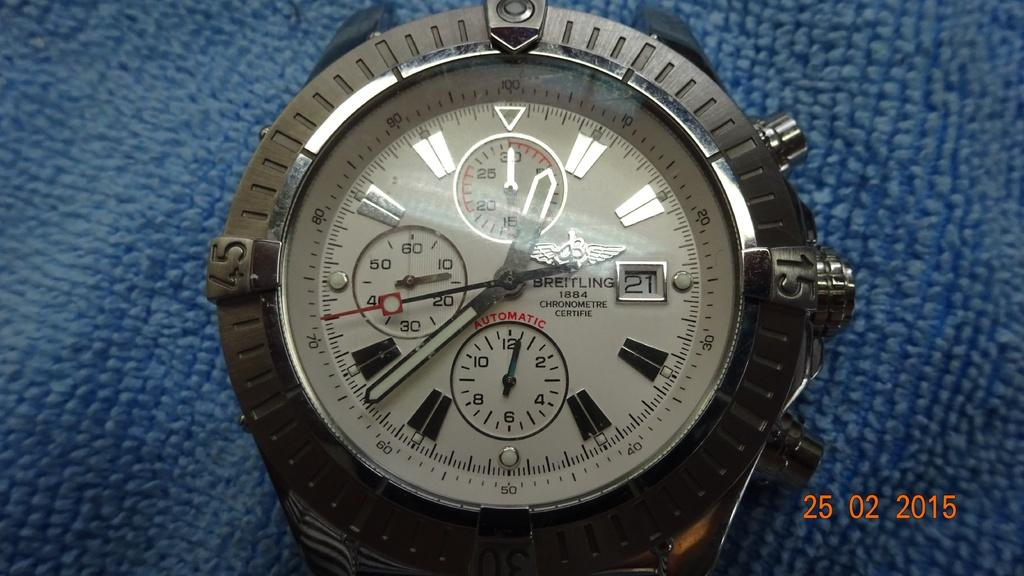<image>
Render a clear and concise summary of the photo. Face of a wristwatch with the word BREITLING on it. 